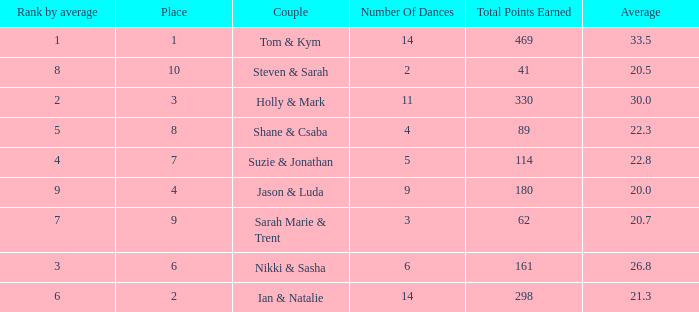What is the number of dances total number if the average is 22.3? 1.0. 